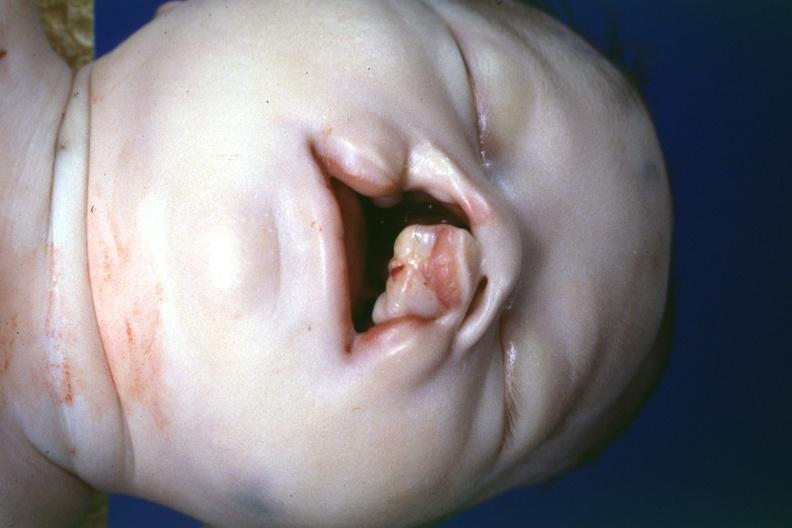s cleft palate present?
Answer the question using a single word or phrase. Yes 